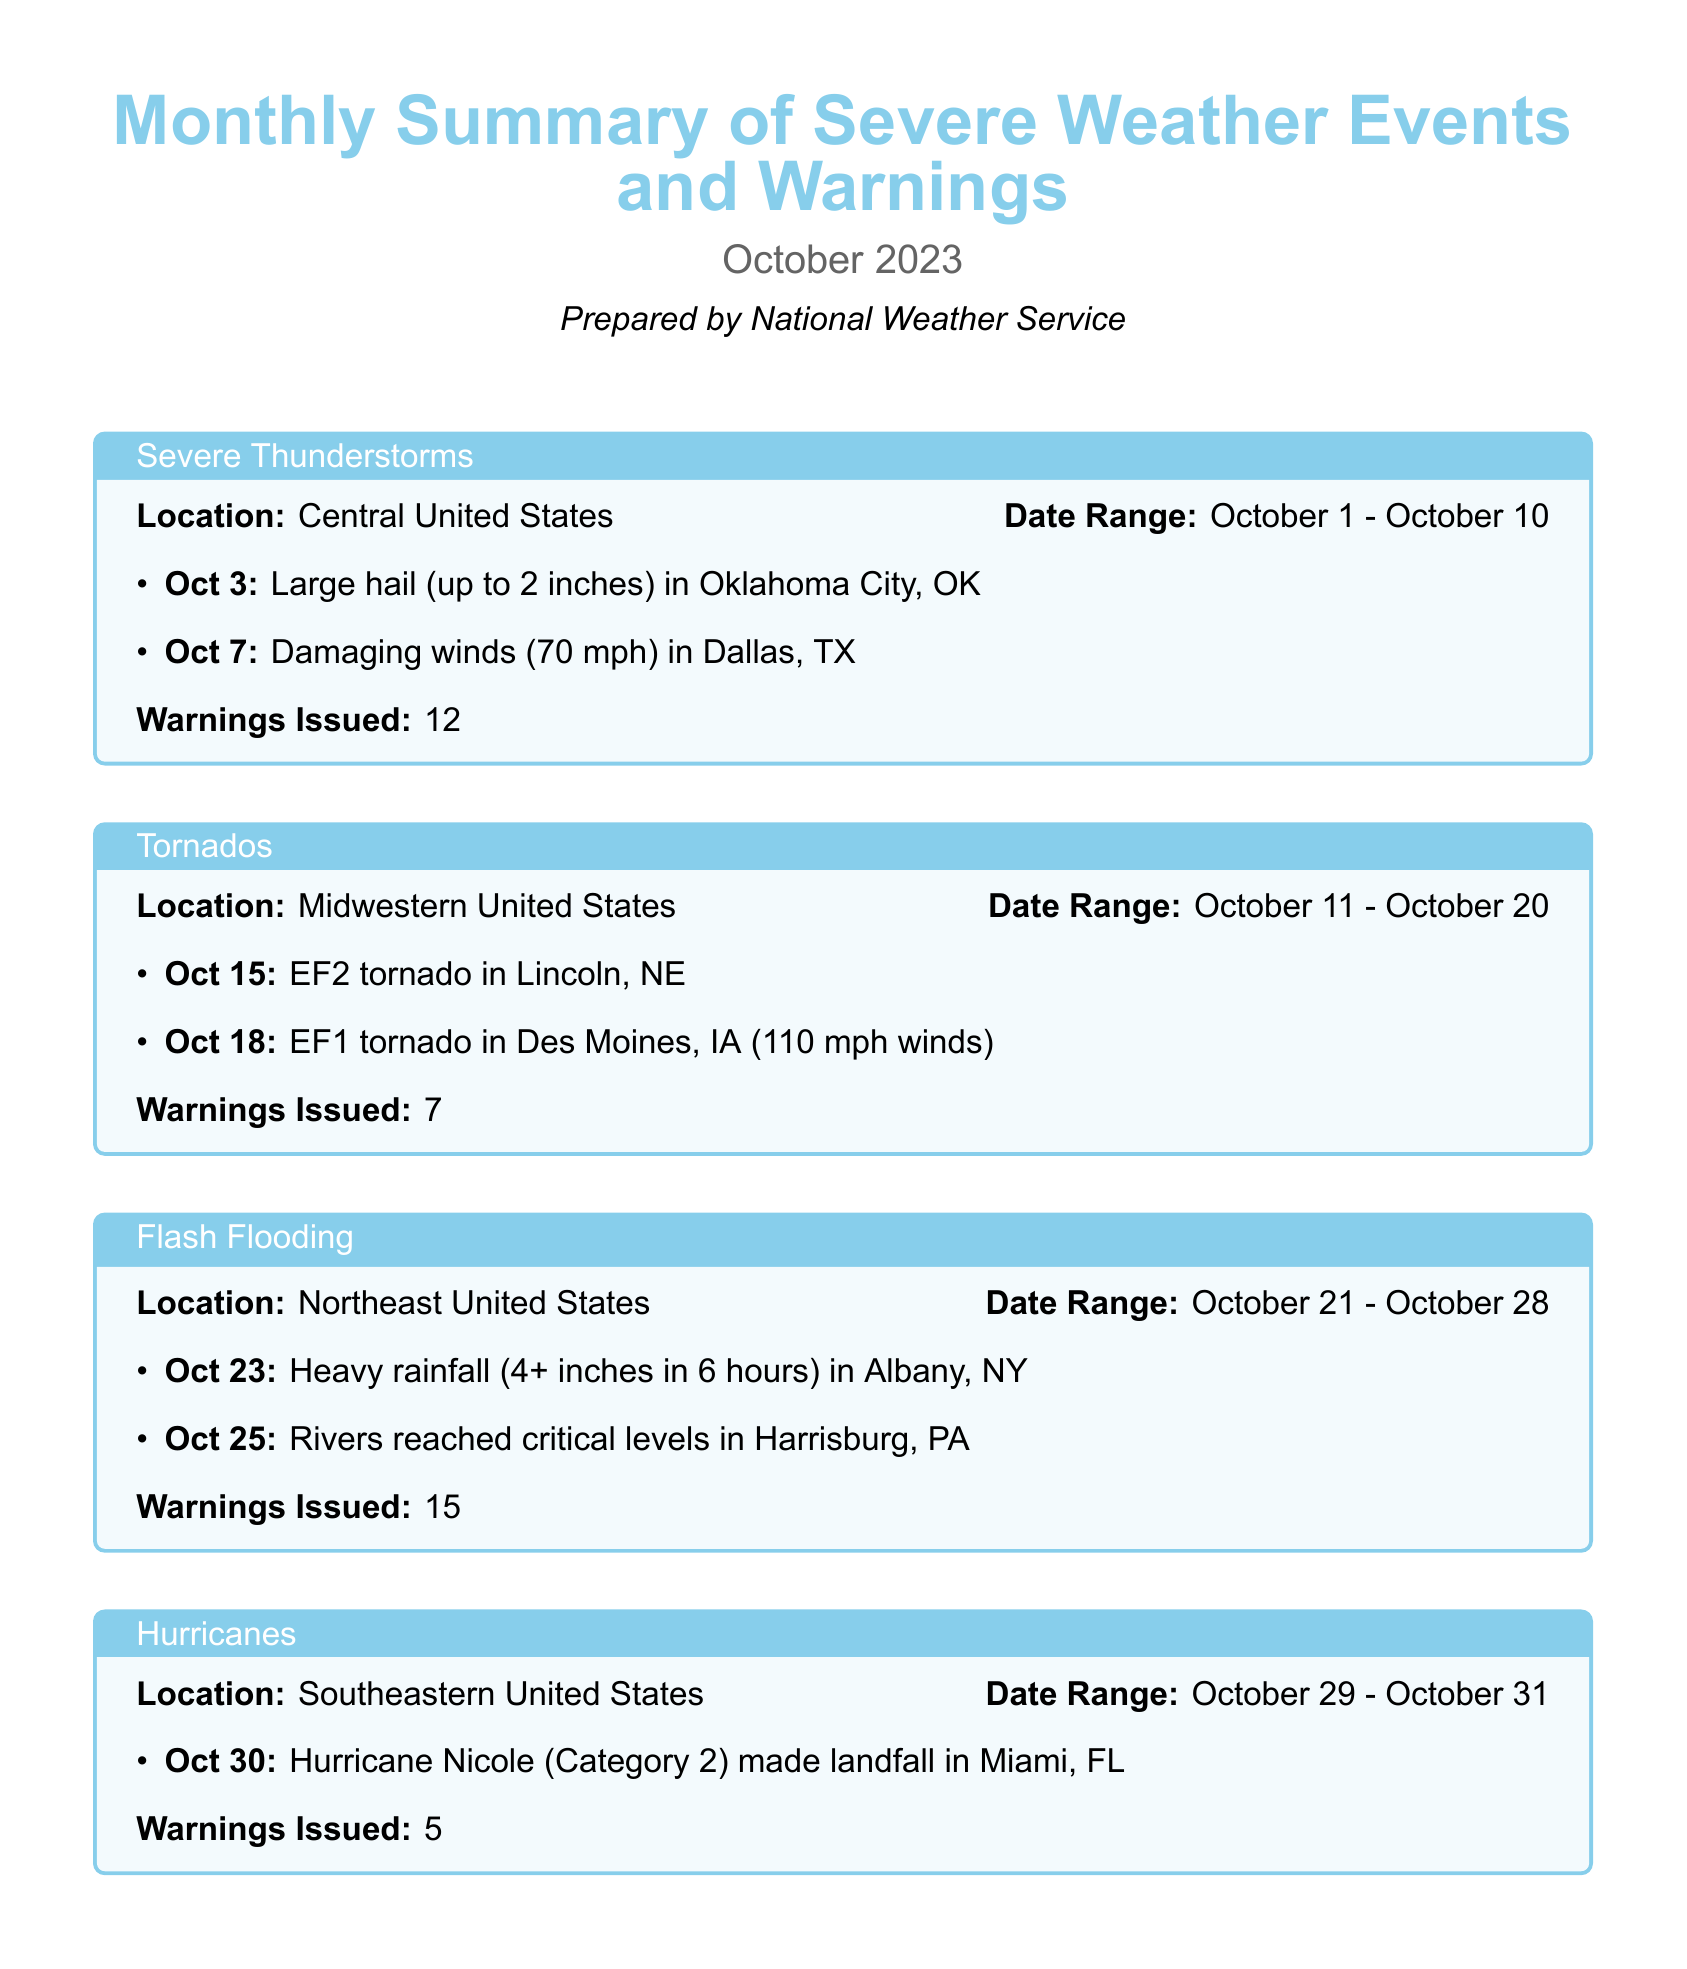what was the total number of warnings issued? The total number of warnings is noted in the final summary section of the document.
Answer: 39 how many severe thunderstorm warnings were issued? The number of severe thunderstorm warnings is mentioned in the section specifically about severe thunderstorms.
Answer: 12 what was the highest wind speed recorded during the tornado events? The highest wind speed is specified in the event details for the EF1 tornado in Des Moines, IA.
Answer: 110 mph in which state did Hurricane Nicole make landfall? The document indicates the location of Hurricane Nicole's landfall in the hurricanes section.
Answer: Miami, FL what type of tornado occurred in Lincoln, NE? The specific type of tornado is listed in the description of the tornado event in Lincoln, NE.
Answer: EF2 during which date range did flash flooding occur? The date range for flash flooding events is provided in the section about flash flooding.
Answer: October 21 - October 28 how much rainfall was recorded during the heavy rainfall event in Albany, NY? The amount of rainfall is detailed in the description of the heavy rainfall event in Albany, NY.
Answer: 4+ inches what were the major severe weather events reported in October? The document lists four major types of severe weather events across the different sections.
Answer: Severe Thunderstorms, Tornados, Flash Flooding, Hurricanes 